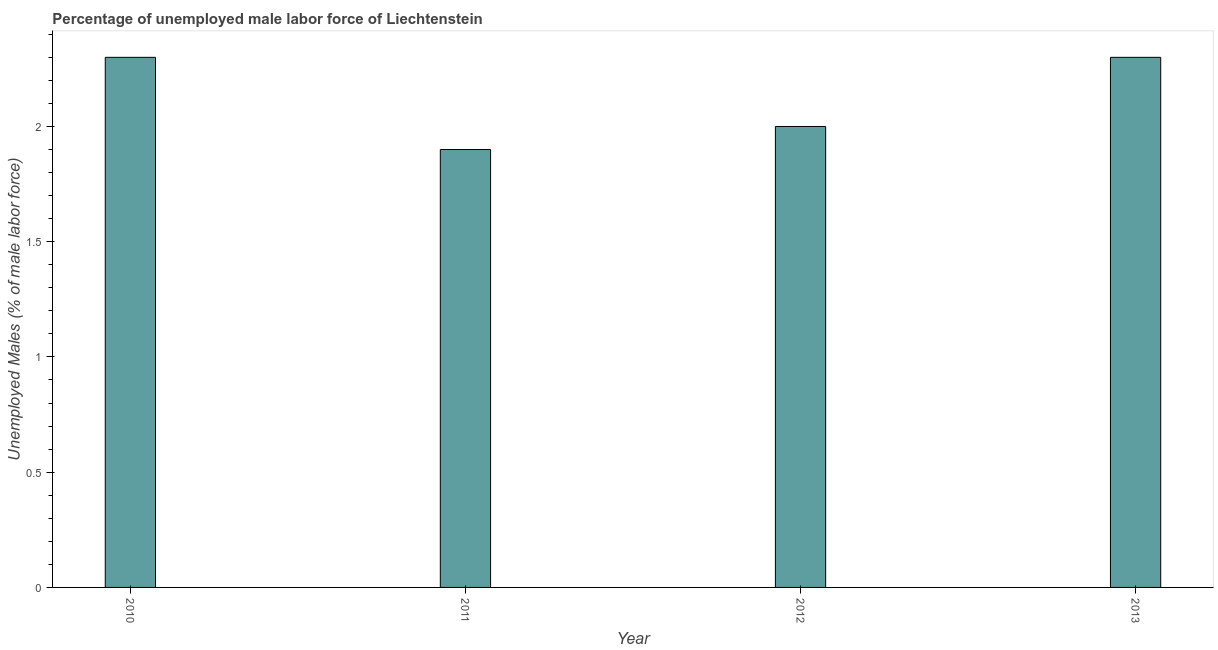Does the graph contain any zero values?
Your answer should be very brief. No. Does the graph contain grids?
Ensure brevity in your answer.  No. What is the title of the graph?
Ensure brevity in your answer.  Percentage of unemployed male labor force of Liechtenstein. What is the label or title of the X-axis?
Keep it short and to the point. Year. What is the label or title of the Y-axis?
Ensure brevity in your answer.  Unemployed Males (% of male labor force). Across all years, what is the maximum total unemployed male labour force?
Ensure brevity in your answer.  2.3. Across all years, what is the minimum total unemployed male labour force?
Offer a very short reply. 1.9. In which year was the total unemployed male labour force minimum?
Your answer should be very brief. 2011. What is the sum of the total unemployed male labour force?
Provide a succinct answer. 8.5. What is the difference between the total unemployed male labour force in 2011 and 2012?
Give a very brief answer. -0.1. What is the average total unemployed male labour force per year?
Provide a short and direct response. 2.12. What is the median total unemployed male labour force?
Provide a short and direct response. 2.15. What is the ratio of the total unemployed male labour force in 2012 to that in 2013?
Your answer should be compact. 0.87. Is the difference between the total unemployed male labour force in 2012 and 2013 greater than the difference between any two years?
Your response must be concise. No. What is the difference between the highest and the second highest total unemployed male labour force?
Offer a terse response. 0. In how many years, is the total unemployed male labour force greater than the average total unemployed male labour force taken over all years?
Offer a very short reply. 2. Are all the bars in the graph horizontal?
Provide a short and direct response. No. What is the Unemployed Males (% of male labor force) in 2010?
Your response must be concise. 2.3. What is the Unemployed Males (% of male labor force) of 2011?
Make the answer very short. 1.9. What is the Unemployed Males (% of male labor force) in 2012?
Provide a short and direct response. 2. What is the Unemployed Males (% of male labor force) in 2013?
Your answer should be compact. 2.3. What is the difference between the Unemployed Males (% of male labor force) in 2010 and 2011?
Keep it short and to the point. 0.4. What is the difference between the Unemployed Males (% of male labor force) in 2010 and 2013?
Your response must be concise. 0. What is the difference between the Unemployed Males (% of male labor force) in 2011 and 2012?
Your response must be concise. -0.1. What is the difference between the Unemployed Males (% of male labor force) in 2011 and 2013?
Your answer should be very brief. -0.4. What is the ratio of the Unemployed Males (% of male labor force) in 2010 to that in 2011?
Keep it short and to the point. 1.21. What is the ratio of the Unemployed Males (% of male labor force) in 2010 to that in 2012?
Offer a terse response. 1.15. What is the ratio of the Unemployed Males (% of male labor force) in 2011 to that in 2012?
Provide a short and direct response. 0.95. What is the ratio of the Unemployed Males (% of male labor force) in 2011 to that in 2013?
Keep it short and to the point. 0.83. What is the ratio of the Unemployed Males (% of male labor force) in 2012 to that in 2013?
Keep it short and to the point. 0.87. 